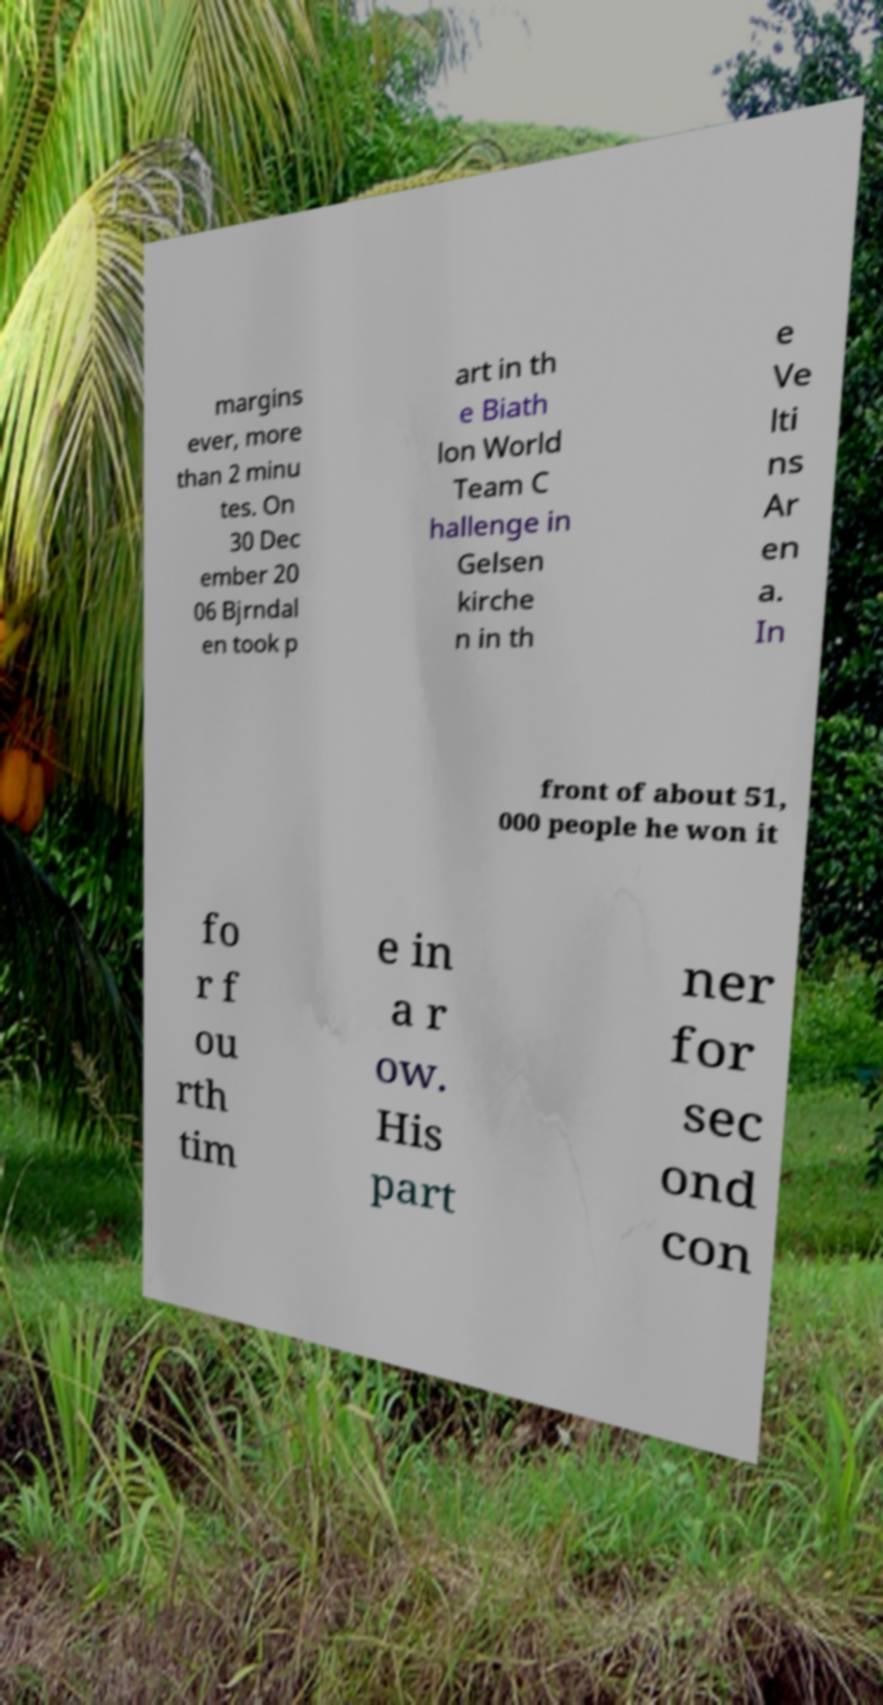Could you assist in decoding the text presented in this image and type it out clearly? margins ever, more than 2 minu tes. On 30 Dec ember 20 06 Bjrndal en took p art in th e Biath lon World Team C hallenge in Gelsen kirche n in th e Ve lti ns Ar en a. In front of about 51, 000 people he won it fo r f ou rth tim e in a r ow. His part ner for sec ond con 